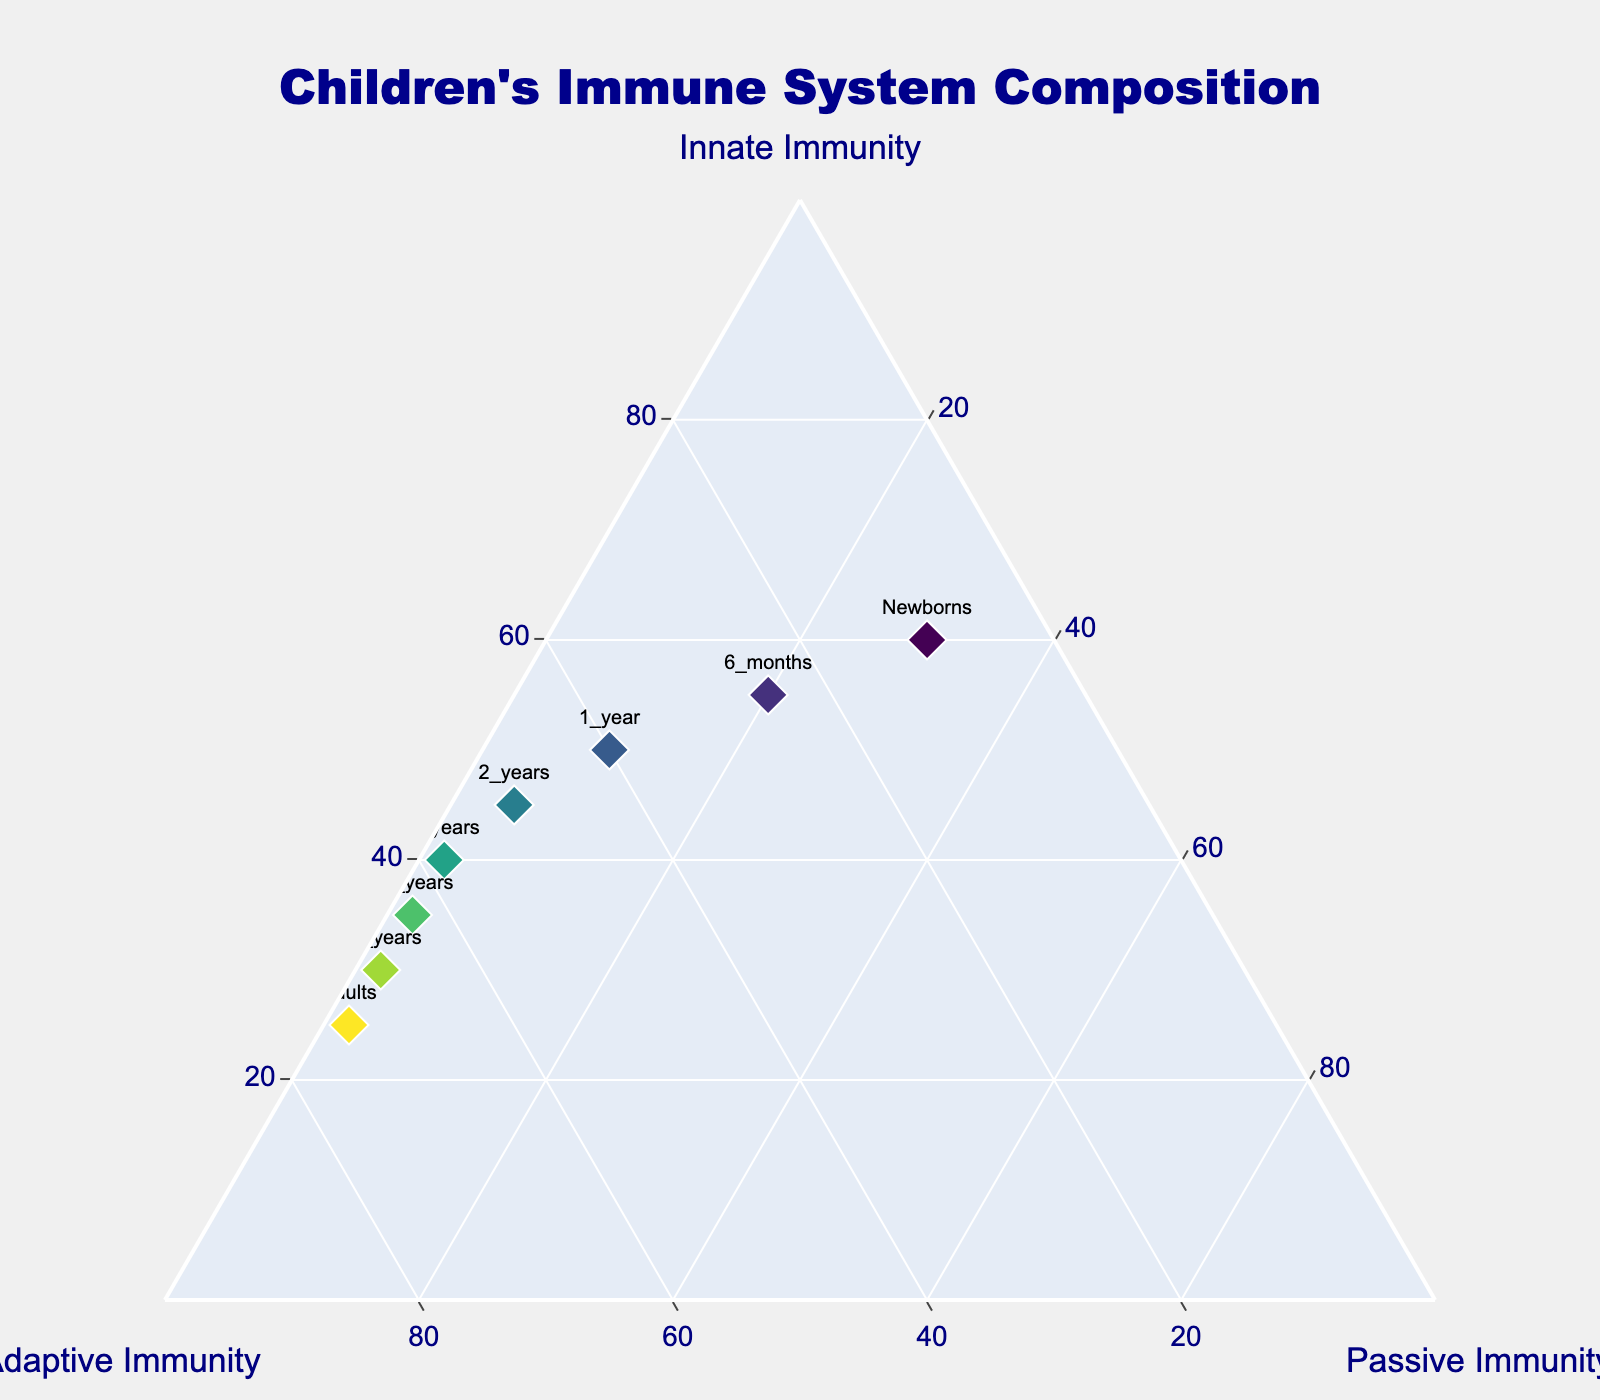What is the title of the figure? The title is located at the top of the figure and is prominently displayed in a large font size. By reading this text, you can identify the title.
Answer: Children's Immune System Composition Which age group has the highest value of passive immunity? Looking at the figure, you notice that 'Newborns' has the highest value marked under "Passive Immunity" on the ternary plot.
Answer: Newborns How does the ratio of innate to adaptive immunity change from newborns to 10 years? To answer this, inspect the points for 'Newborns' and '10_years'. Newborns have 60% innate and 10% adaptive immunity, a ratio of 6:1. At 10 years, it's 35% innate and 63% adaptive immunity, a ratio of approximately 0.56:1.
Answer: Decreases What is the difference in innate immunity between 1 year and adults? Refer to the plot: 1 year has 50% innate immunity and adults have 25%. The difference is calculated as 50% - 25%.
Answer: 25% Which age group has equal percentages of adaptive and innate immunity? Locate the points on the plot and compare their values. At 2 years, both adaptive and innate immunity are approximately equal at 50%.
Answer: 2 years What trend is observed in adaptive immunity from newborns to adults? Begin at the 'Newborns' point and trace to 'Adults'. Adaptive immunity starts at 10% in newborns and increases gradually to 73% in adults.
Answer: Increasing Which two age groups have the closest values for passive immunity? Compare passive immunity values across the data points and find that 10_years, 15_years, and Adults all have 2%. Therefore, these groups have the closest values.
Answer: 10 years, 15 years, Adults Calculate the average percentage of innate immunity for the age groups 6 months, 2 years, and 5 years. Sum the percentages of innate immunity for these age groups (55% + 45% + 40%) and divide by 3 to get the average.
Answer: 46.67% How does passive immunity change from 6 months to 1 year? Observe the points for 6 months and 1 year: Passive immunity decreases from 20% at 6 months to 10% at 1 year.
Answer: Decreases 